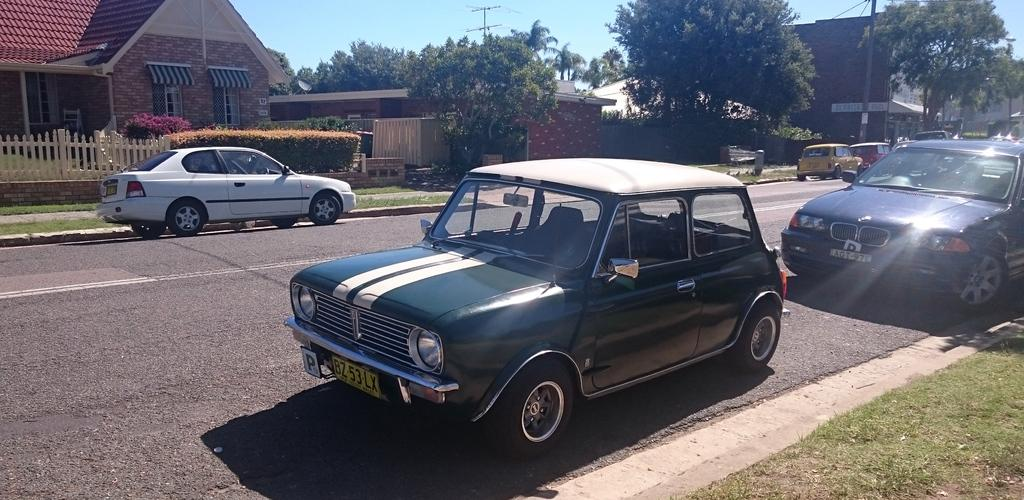What type of vehicles can be seen on the road in the image? There are cars on the road in the image. What structures are visible in the image? There are buildings in the image. What type of vegetation is present in the image? There are trees in the image. What type of barrier can be seen in the image? There is a fence in the image. What vertical structures are present in the image? There are poles in the image. What is visible in the background of the image? The sky is visible in the background of the image. What type of butter is being used to grease the poles in the image? There is no butter present in the image, and the poles are not being greased. What type of plants are growing on the cars in the image? There are no plants growing on the cars in the image. 